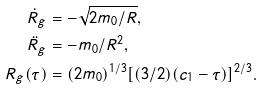<formula> <loc_0><loc_0><loc_500><loc_500>\dot { R } _ { g } & = - \sqrt { 2 m _ { 0 } / R } , \\ \ddot { R } _ { g } & = - m _ { 0 } / R ^ { 2 } , \\ R _ { g } ( \tau ) & = ( 2 m _ { 0 } ) ^ { 1 / 3 } [ ( 3 / 2 ) ( c _ { 1 } - \tau ) ] ^ { 2 / 3 } .</formula> 